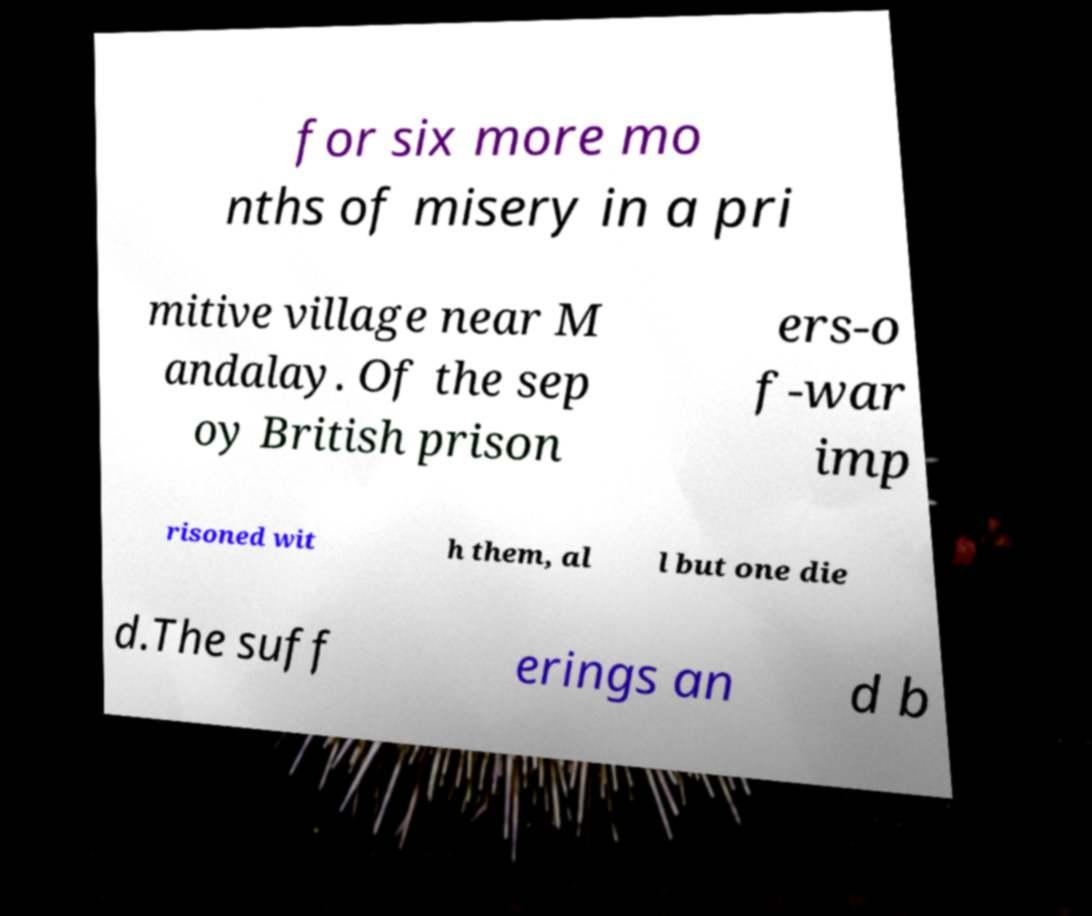Can you read and provide the text displayed in the image?This photo seems to have some interesting text. Can you extract and type it out for me? for six more mo nths of misery in a pri mitive village near M andalay. Of the sep oy British prison ers-o f-war imp risoned wit h them, al l but one die d.The suff erings an d b 